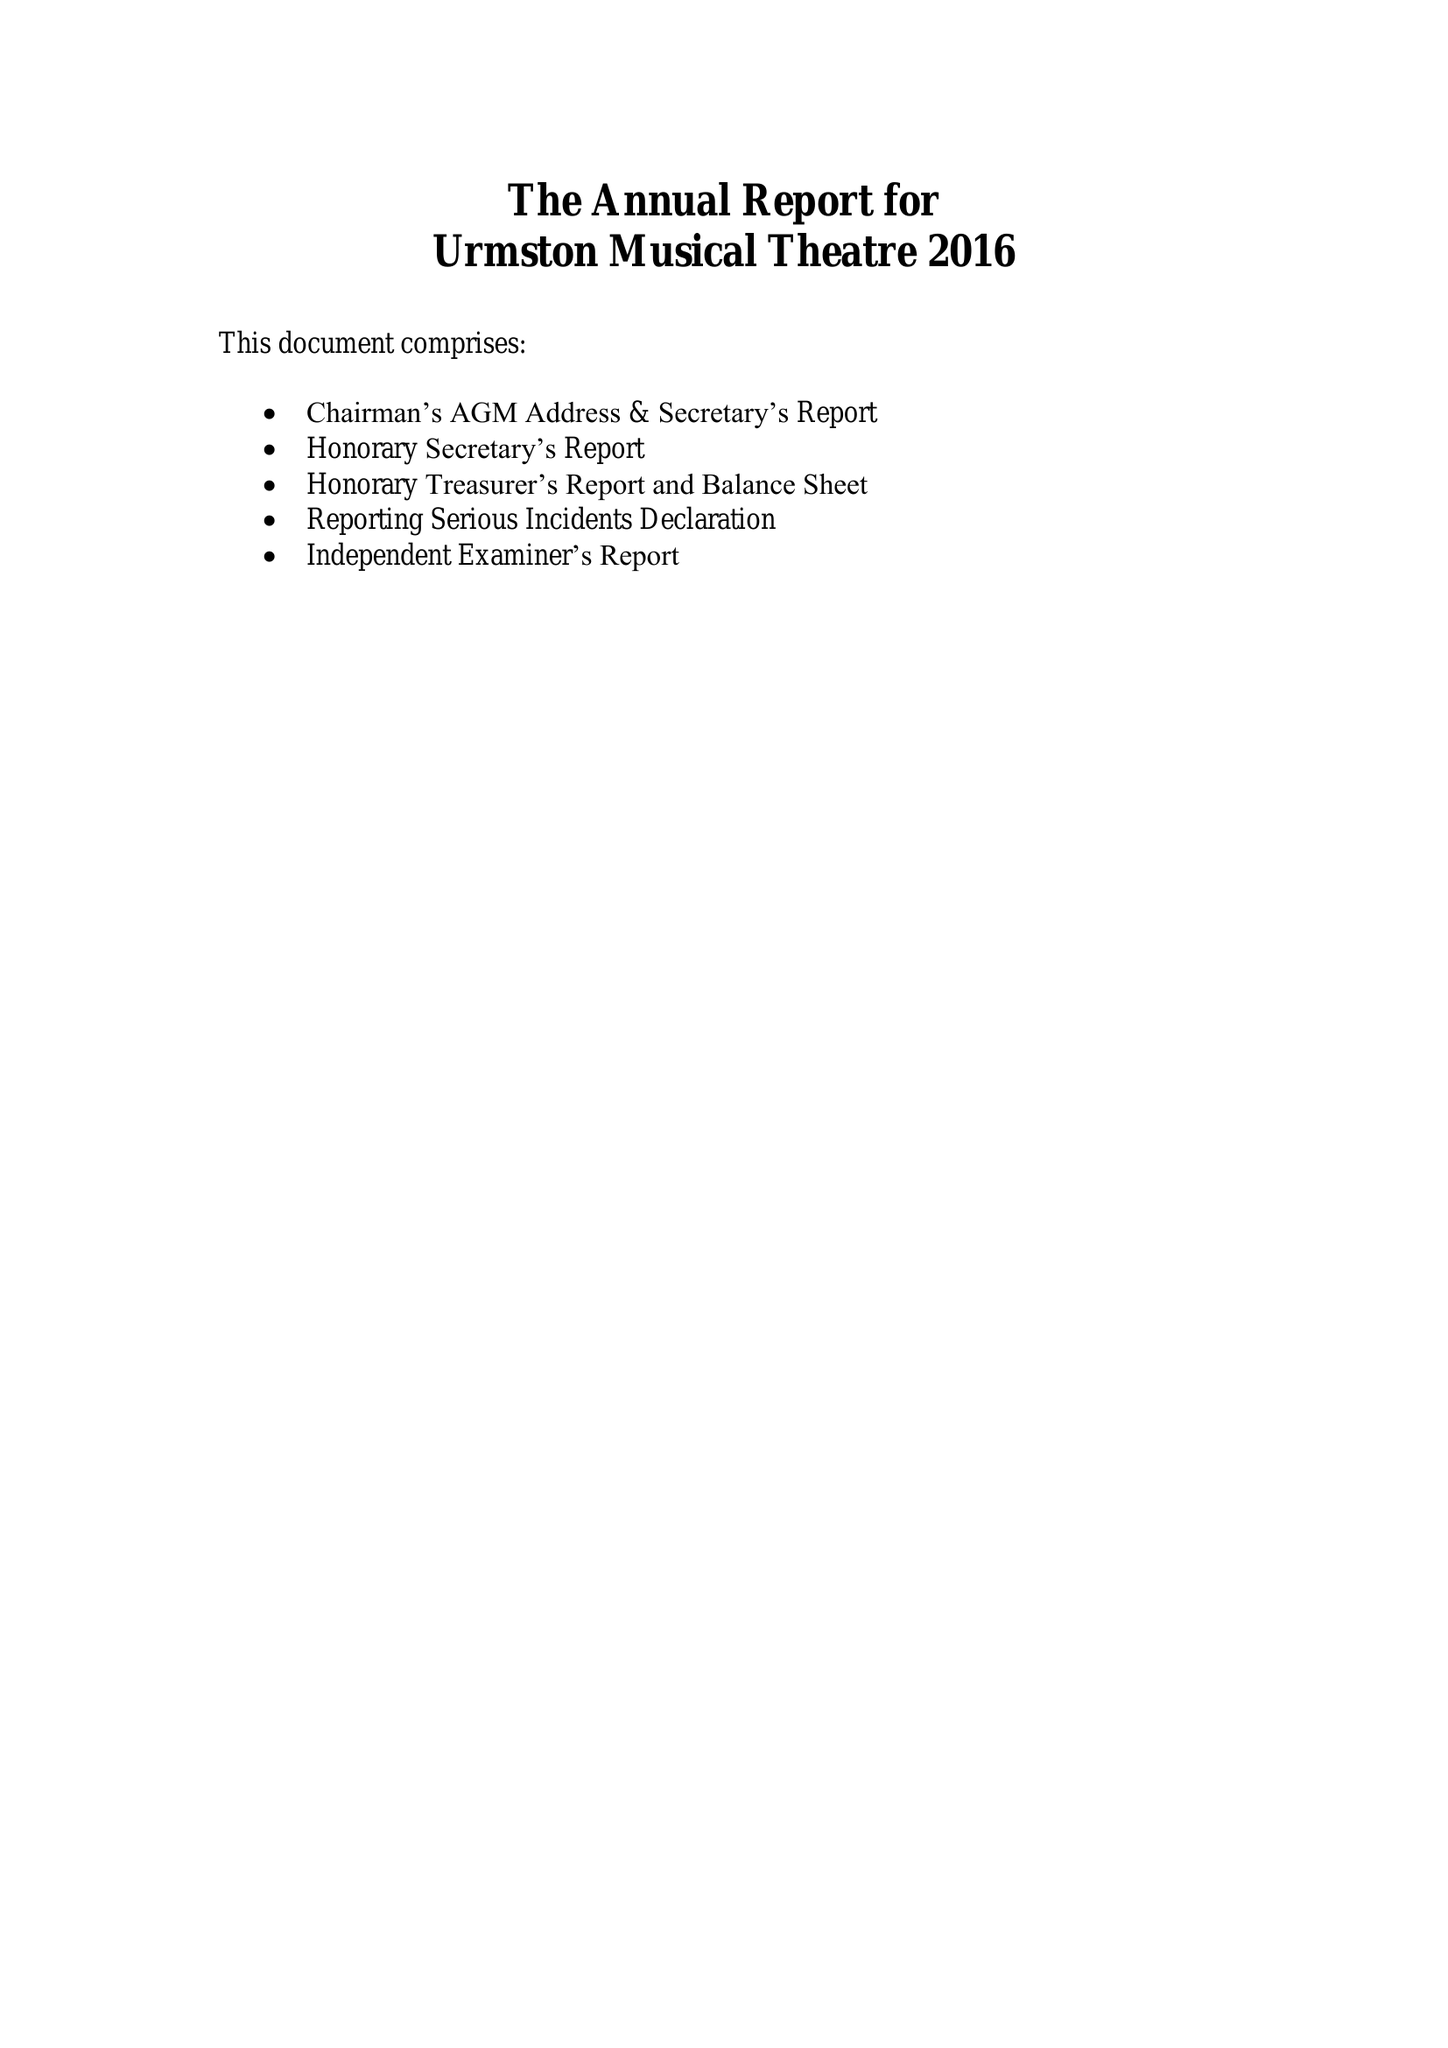What is the value for the charity_number?
Answer the question using a single word or phrase. 1119510 